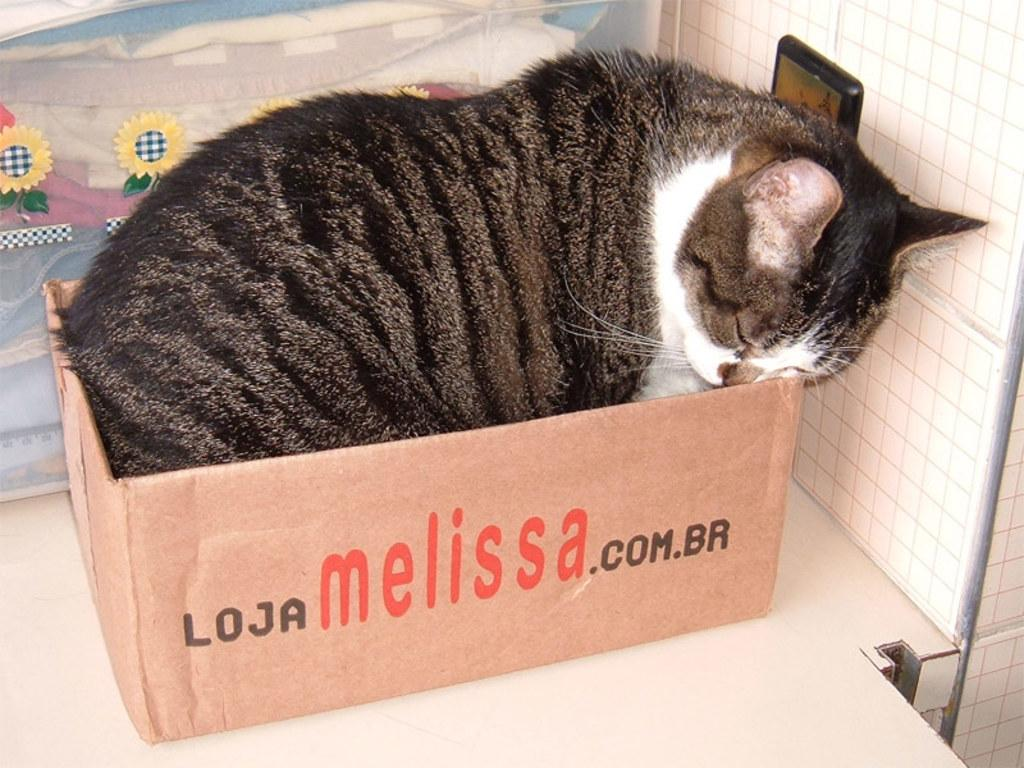What animal can be seen in the image? There is a cat in the image. Where is the cat located? The cat is in a box. What is the box resting on? The box is on a desk. What is visible at the top of the image? There is a poster at the top of the image. What type of lighting is present in the image? There is a light attached to the wall on the right side of the image. What type of lace is used to decorate the cat's box in the image? There is no lace present in the image; the cat's box is plain. What time of day is depicted in the image? The time of day cannot be determined from the image, as there are no clues or indicators present. 